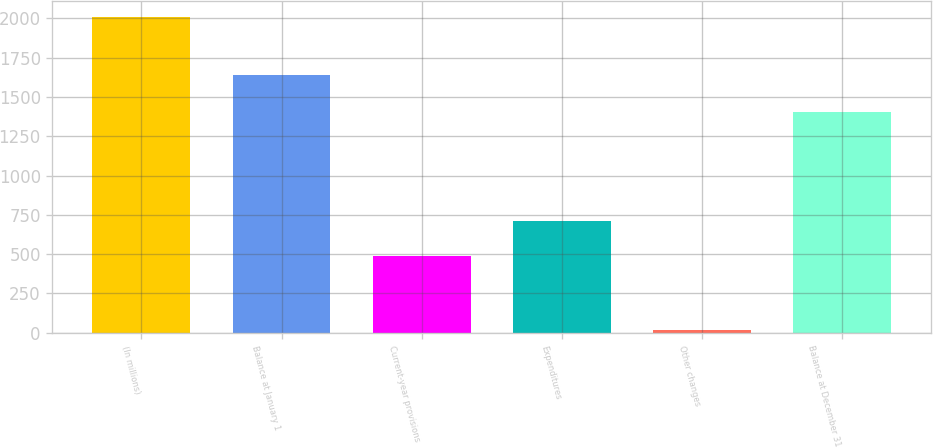<chart> <loc_0><loc_0><loc_500><loc_500><bar_chart><fcel>(In millions)<fcel>Balance at January 1<fcel>Current-year provisions<fcel>Expenditures<fcel>Other changes<fcel>Balance at December 31<nl><fcel>2010<fcel>1641<fcel>491<fcel>710<fcel>17<fcel>1405<nl></chart> 